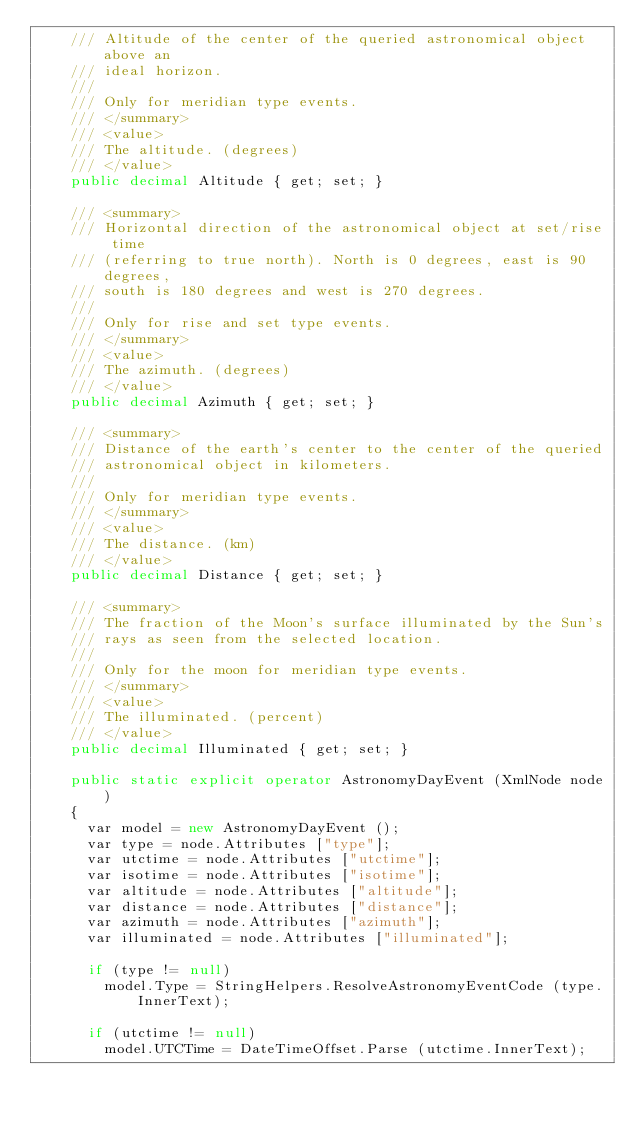<code> <loc_0><loc_0><loc_500><loc_500><_C#_>		/// Altitude of the center of the queried astronomical object above an 
		/// ideal horizon.
		/// 
		/// Only for meridian type events.
		/// </summary>
		/// <value>
		/// The altitude. (degrees)
		/// </value>
		public decimal Altitude { get; set; }
		
		/// <summary>
		/// Horizontal direction of the astronomical object at set/rise time 
		/// (referring to true north). North is 0 degrees, east is 90 degrees, 
		/// south is 180 degrees and west is 270 degrees.
		/// 
		/// Only for rise and set type events.
		/// </summary>
		/// <value>
		/// The azimuth. (degrees)
		/// </value>
		public decimal Azimuth { get; set; }
		
		/// <summary>
		/// Distance of the earth's center to the center of the queried 
		/// astronomical object in kilometers.
		/// 
		/// Only for meridian type events.
		/// </summary>
		/// <value>
		/// The distance. (km)
		/// </value>
		public decimal Distance { get; set; }
		
		/// <summary>
		/// The fraction of the Moon's surface illuminated by the Sun's 
		/// rays as seen from the selected location.
		/// 
		/// Only for the moon for meridian type events.
		/// </summary>
		/// <value>
		/// The illuminated. (percent)
		/// </value>
		public decimal Illuminated { get; set; }
		
		public static explicit operator AstronomyDayEvent (XmlNode node)
		{
			var model = new AstronomyDayEvent ();
			var type = node.Attributes ["type"];
			var utctime = node.Attributes ["utctime"];
			var isotime = node.Attributes ["isotime"];
			var altitude = node.Attributes ["altitude"];
			var distance = node.Attributes ["distance"];
			var azimuth = node.Attributes ["azimuth"];
			var illuminated = node.Attributes ["illuminated"];
			
			if (type != null)
				model.Type = StringHelpers.ResolveAstronomyEventCode (type.InnerText);
			
			if (utctime != null)
				model.UTCTime = DateTimeOffset.Parse (utctime.InnerText);</code> 